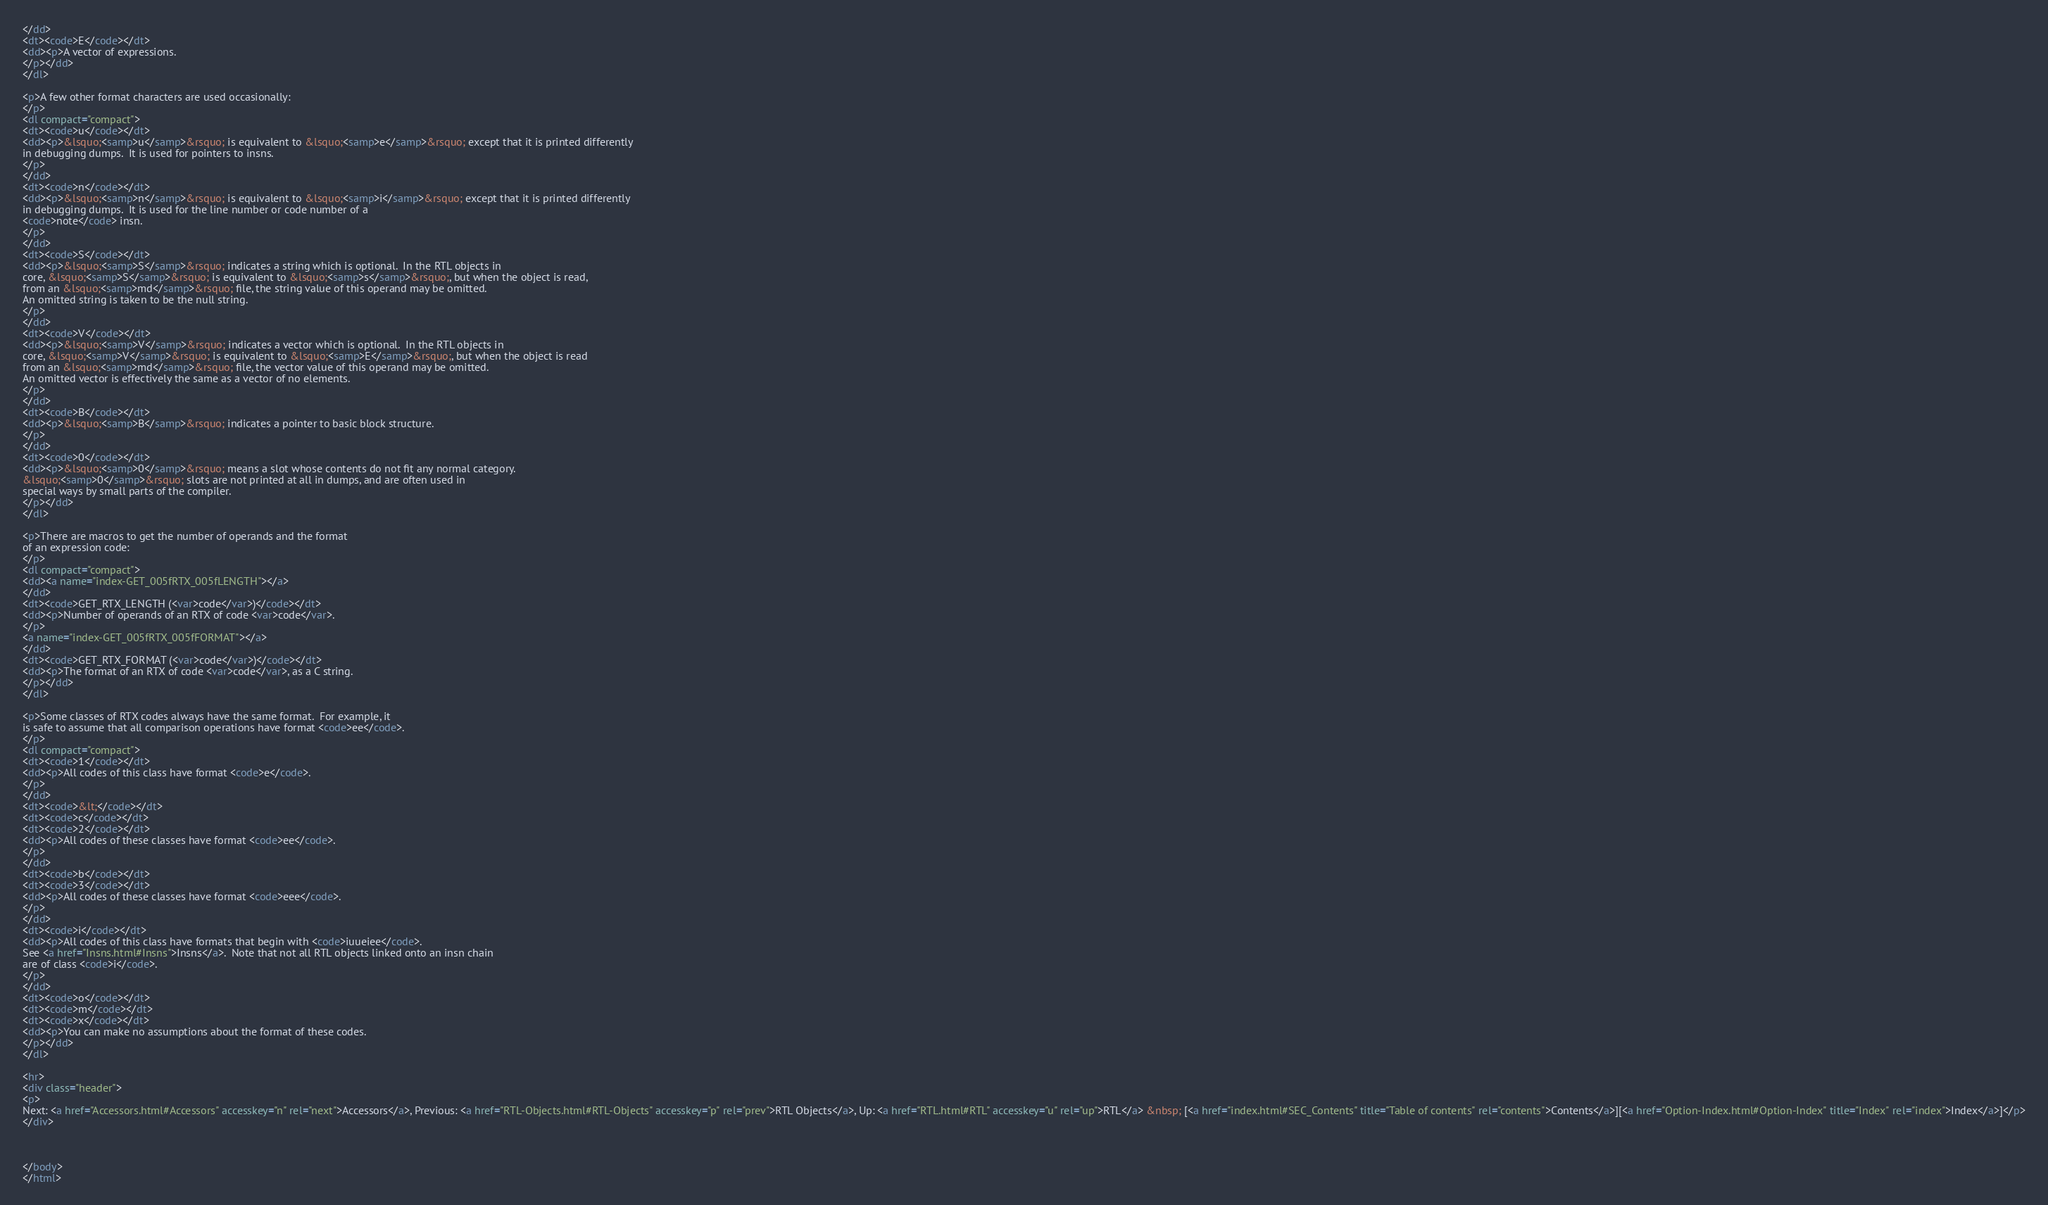Convert code to text. <code><loc_0><loc_0><loc_500><loc_500><_HTML_></dd>
<dt><code>E</code></dt>
<dd><p>A vector of expressions.
</p></dd>
</dl>

<p>A few other format characters are used occasionally:
</p>
<dl compact="compact">
<dt><code>u</code></dt>
<dd><p>&lsquo;<samp>u</samp>&rsquo; is equivalent to &lsquo;<samp>e</samp>&rsquo; except that it is printed differently
in debugging dumps.  It is used for pointers to insns.
</p>
</dd>
<dt><code>n</code></dt>
<dd><p>&lsquo;<samp>n</samp>&rsquo; is equivalent to &lsquo;<samp>i</samp>&rsquo; except that it is printed differently
in debugging dumps.  It is used for the line number or code number of a
<code>note</code> insn.
</p>
</dd>
<dt><code>S</code></dt>
<dd><p>&lsquo;<samp>S</samp>&rsquo; indicates a string which is optional.  In the RTL objects in
core, &lsquo;<samp>S</samp>&rsquo; is equivalent to &lsquo;<samp>s</samp>&rsquo;, but when the object is read,
from an &lsquo;<samp>md</samp>&rsquo; file, the string value of this operand may be omitted.
An omitted string is taken to be the null string.
</p>
</dd>
<dt><code>V</code></dt>
<dd><p>&lsquo;<samp>V</samp>&rsquo; indicates a vector which is optional.  In the RTL objects in
core, &lsquo;<samp>V</samp>&rsquo; is equivalent to &lsquo;<samp>E</samp>&rsquo;, but when the object is read
from an &lsquo;<samp>md</samp>&rsquo; file, the vector value of this operand may be omitted.
An omitted vector is effectively the same as a vector of no elements.
</p>
</dd>
<dt><code>B</code></dt>
<dd><p>&lsquo;<samp>B</samp>&rsquo; indicates a pointer to basic block structure.
</p>
</dd>
<dt><code>0</code></dt>
<dd><p>&lsquo;<samp>0</samp>&rsquo; means a slot whose contents do not fit any normal category.
&lsquo;<samp>0</samp>&rsquo; slots are not printed at all in dumps, and are often used in
special ways by small parts of the compiler.
</p></dd>
</dl>

<p>There are macros to get the number of operands and the format
of an expression code:
</p>
<dl compact="compact">
<dd><a name="index-GET_005fRTX_005fLENGTH"></a>
</dd>
<dt><code>GET_RTX_LENGTH (<var>code</var>)</code></dt>
<dd><p>Number of operands of an RTX of code <var>code</var>.
</p>
<a name="index-GET_005fRTX_005fFORMAT"></a>
</dd>
<dt><code>GET_RTX_FORMAT (<var>code</var>)</code></dt>
<dd><p>The format of an RTX of code <var>code</var>, as a C string.
</p></dd>
</dl>

<p>Some classes of RTX codes always have the same format.  For example, it
is safe to assume that all comparison operations have format <code>ee</code>.
</p>
<dl compact="compact">
<dt><code>1</code></dt>
<dd><p>All codes of this class have format <code>e</code>.
</p>
</dd>
<dt><code>&lt;</code></dt>
<dt><code>c</code></dt>
<dt><code>2</code></dt>
<dd><p>All codes of these classes have format <code>ee</code>.
</p>
</dd>
<dt><code>b</code></dt>
<dt><code>3</code></dt>
<dd><p>All codes of these classes have format <code>eee</code>.
</p>
</dd>
<dt><code>i</code></dt>
<dd><p>All codes of this class have formats that begin with <code>iuueiee</code>.
See <a href="Insns.html#Insns">Insns</a>.  Note that not all RTL objects linked onto an insn chain
are of class <code>i</code>.
</p>
</dd>
<dt><code>o</code></dt>
<dt><code>m</code></dt>
<dt><code>x</code></dt>
<dd><p>You can make no assumptions about the format of these codes.
</p></dd>
</dl>

<hr>
<div class="header">
<p>
Next: <a href="Accessors.html#Accessors" accesskey="n" rel="next">Accessors</a>, Previous: <a href="RTL-Objects.html#RTL-Objects" accesskey="p" rel="prev">RTL Objects</a>, Up: <a href="RTL.html#RTL" accesskey="u" rel="up">RTL</a> &nbsp; [<a href="index.html#SEC_Contents" title="Table of contents" rel="contents">Contents</a>][<a href="Option-Index.html#Option-Index" title="Index" rel="index">Index</a>]</p>
</div>



</body>
</html>
</code> 